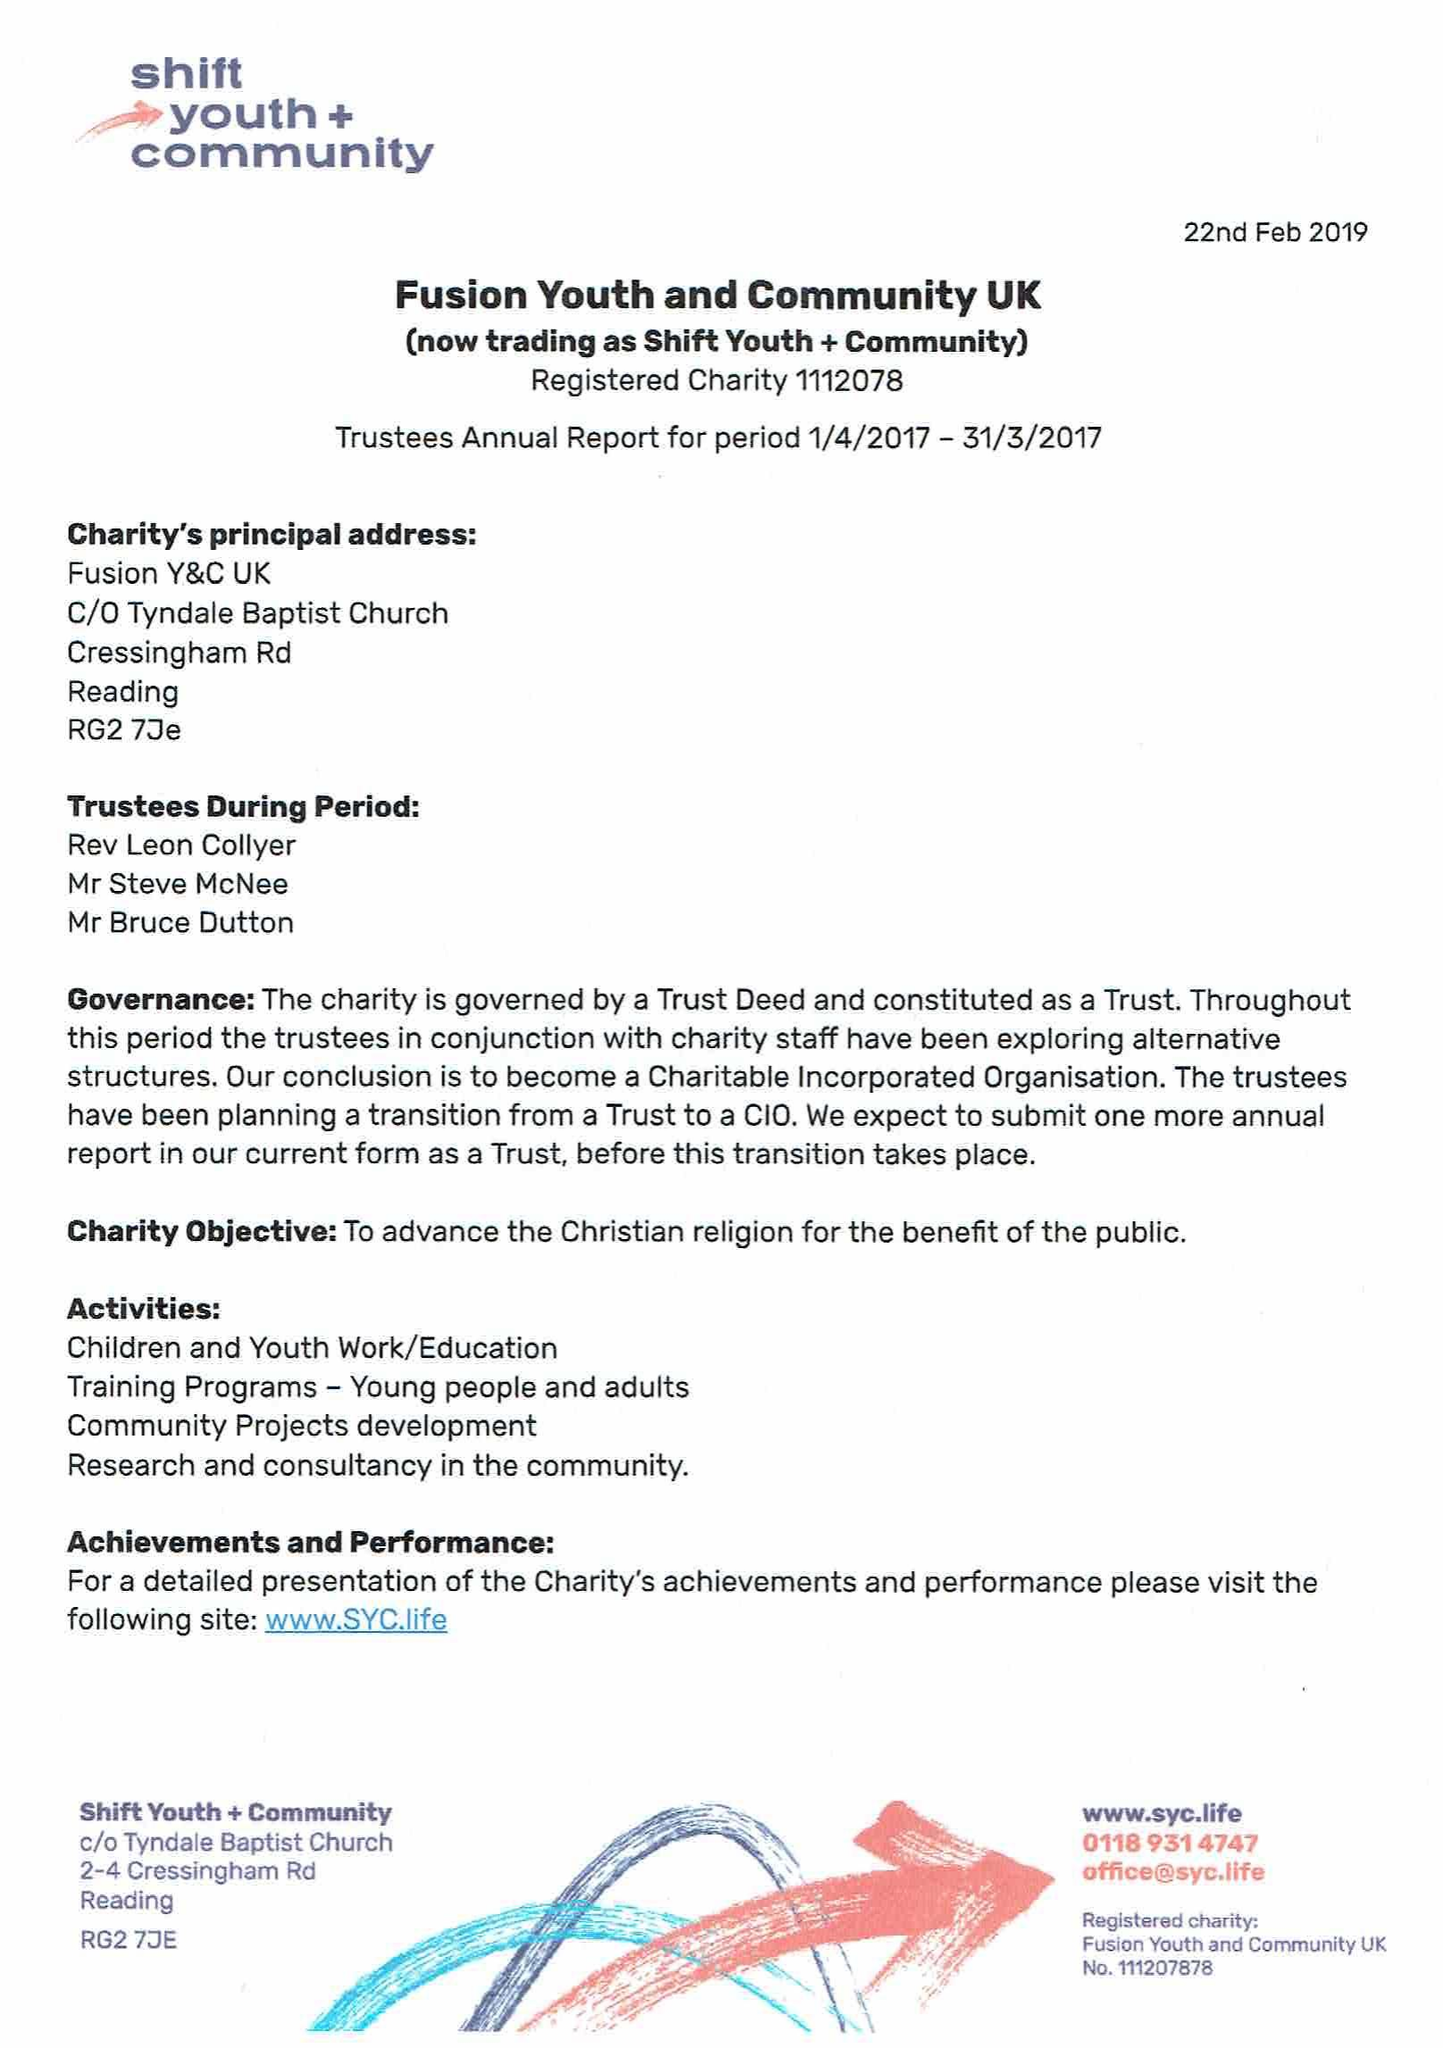What is the value for the spending_annually_in_british_pounds?
Answer the question using a single word or phrase. 50310.00 